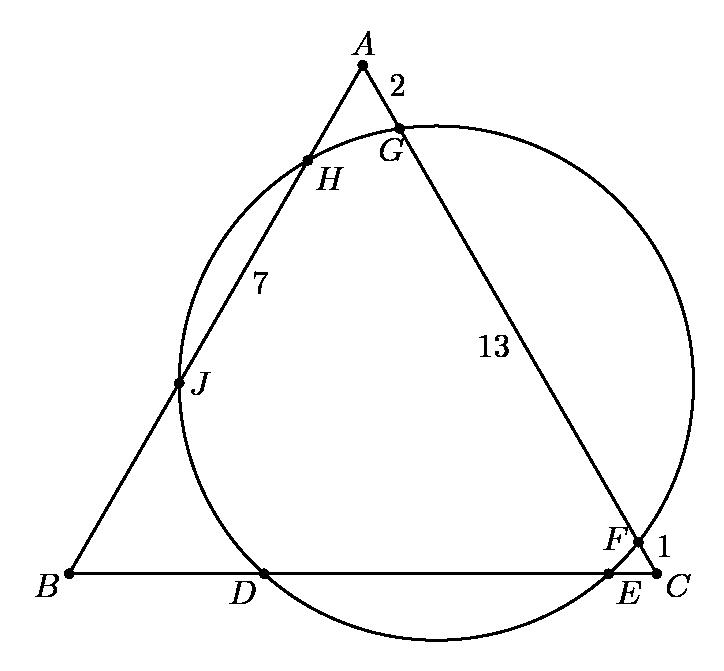In the adjoining figure, the circle meets the sides of an equilateral triangle at six points. If $AG=2$, $GF=13$, $FC=1$, and $HJ=7$, then $DE$ equals
 Choices: ['$2\sqrt{22}$', '$7\sqrt{3}$', '$9$', '$10$', '$13$'] To find $DE$, we notice that this is a geometry problem involving a circle and an equilateral triangle. The line segments $AG=2$, $GF=13$, and $FC=1$ indicate sections of the triangle, and $HJ=7$ reflects a measurement within the structure. Given these dimensions within the geometry, the calculation of $DE$ would involve understanding the relationship between the segments and the properties of the circle and the equilateral triangle. However, a complete step-by-step calculation requires additional geometric analysis which might include applying the triangle sum theorem, properties of an equilateral triangle, or Pythagorean theorem in segments of chords and triangle sides. Without further analysis or clear indication of methodology, pinpointing the exact choice among ['$2\sqrt{22}$', '$7\sqrt{3}$', '$9$', '$10$', '$13$'] becomes speculative. Nonetheless, let's analyze briefly assuming symmetry and specific triangle properties to recommend a sensible approach or choose the plausible option based on geometric principles discussed. 